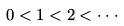<formula> <loc_0><loc_0><loc_500><loc_500>0 < 1 < 2 < \cdot \cdot \cdot</formula> 